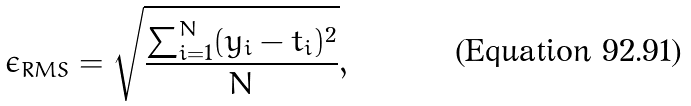Convert formula to latex. <formula><loc_0><loc_0><loc_500><loc_500>\epsilon _ { R M S } = \sqrt { \frac { \sum _ { i = 1 } ^ { N } ( y _ { i } - t _ { i } ) ^ { 2 } } { N } } ,</formula> 